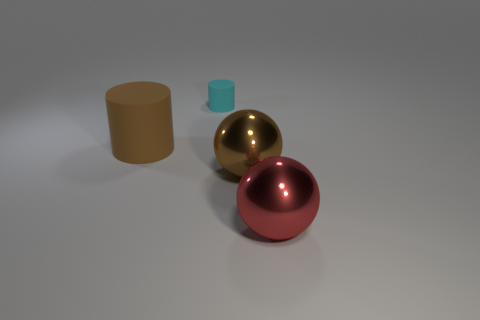How many green objects are big metallic objects or big blocks?
Provide a short and direct response. 0. Is the number of tiny cyan objects that are behind the big cylinder the same as the number of large metal things?
Offer a terse response. No. Is there anything else that has the same size as the cyan rubber cylinder?
Keep it short and to the point. No. What is the color of the other large thing that is the same shape as the big brown shiny object?
Offer a terse response. Red. What number of other brown matte objects have the same shape as the small thing?
Your response must be concise. 1. There is a thing that is the same color as the large cylinder; what material is it?
Keep it short and to the point. Metal. How many brown things are there?
Your answer should be very brief. 2. Are there any small cylinders that have the same material as the tiny cyan object?
Your answer should be very brief. No. The ball that is the same color as the large matte cylinder is what size?
Offer a terse response. Large. There is a ball behind the large red metallic sphere; does it have the same size as the cyan rubber cylinder left of the big brown sphere?
Make the answer very short. No. 